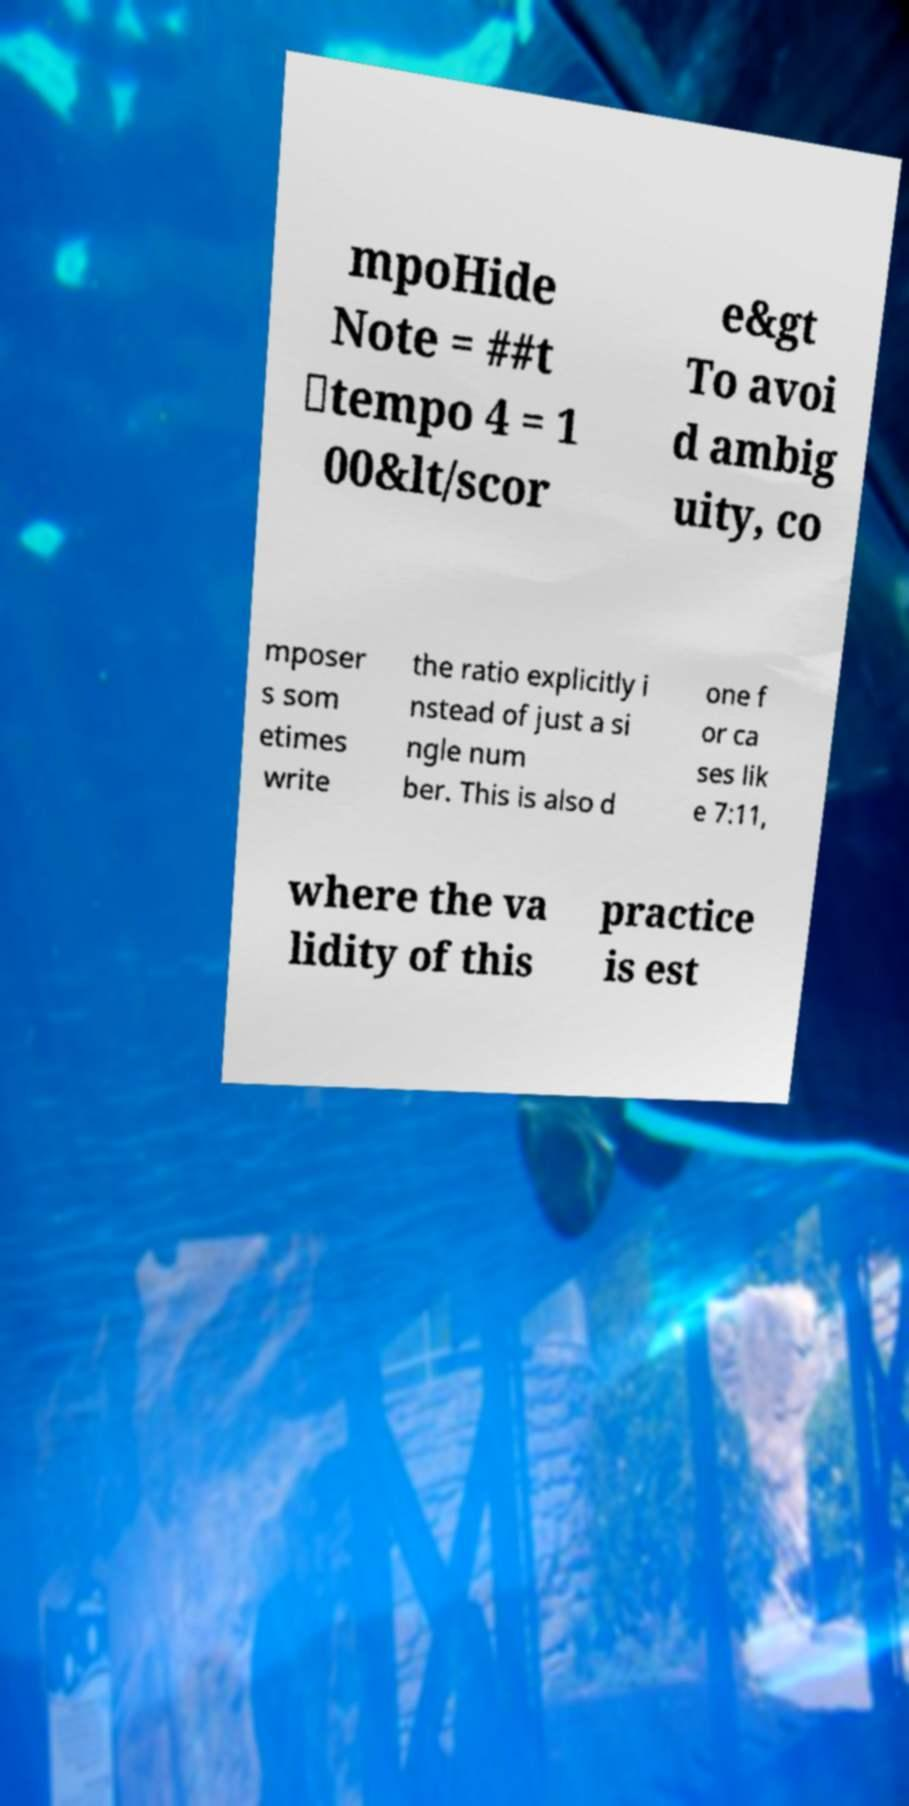There's text embedded in this image that I need extracted. Can you transcribe it verbatim? mpoHide Note = ##t \tempo 4 = 1 00&lt/scor e&gt To avoi d ambig uity, co mposer s som etimes write the ratio explicitly i nstead of just a si ngle num ber. This is also d one f or ca ses lik e 7:11, where the va lidity of this practice is est 